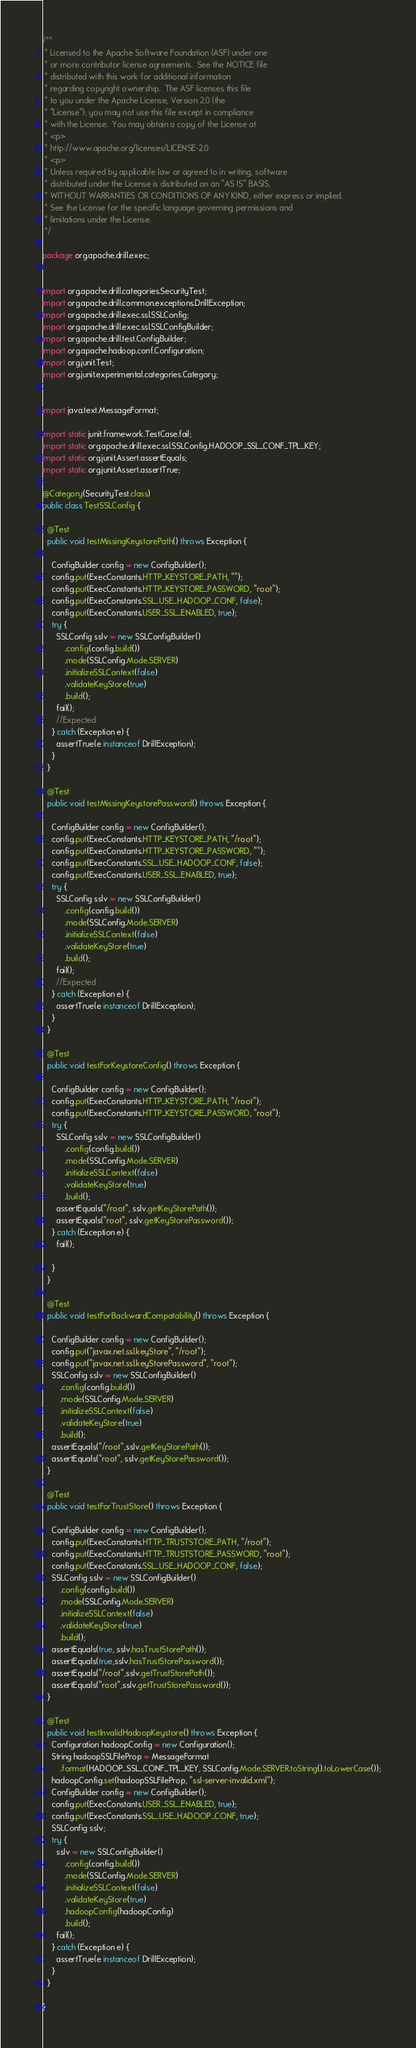Convert code to text. <code><loc_0><loc_0><loc_500><loc_500><_Java_>/**
 * Licensed to the Apache Software Foundation (ASF) under one
 * or more contributor license agreements.  See the NOTICE file
 * distributed with this work for additional information
 * regarding copyright ownership.  The ASF licenses this file
 * to you under the Apache License, Version 2.0 (the
 * "License"); you may not use this file except in compliance
 * with the License.  You may obtain a copy of the License at
 * <p>
 * http://www.apache.org/licenses/LICENSE-2.0
 * <p>
 * Unless required by applicable law or agreed to in writing, software
 * distributed under the License is distributed on an "AS IS" BASIS,
 * WITHOUT WARRANTIES OR CONDITIONS OF ANY KIND, either express or implied.
 * See the License for the specific language governing permissions and
 * limitations under the License.
 */

package org.apache.drill.exec;


import org.apache.drill.categories.SecurityTest;
import org.apache.drill.common.exceptions.DrillException;
import org.apache.drill.exec.ssl.SSLConfig;
import org.apache.drill.exec.ssl.SSLConfigBuilder;
import org.apache.drill.test.ConfigBuilder;
import org.apache.hadoop.conf.Configuration;
import org.junit.Test;
import org.junit.experimental.categories.Category;


import java.text.MessageFormat;

import static junit.framework.TestCase.fail;
import static org.apache.drill.exec.ssl.SSLConfig.HADOOP_SSL_CONF_TPL_KEY;
import static org.junit.Assert.assertEquals;
import static org.junit.Assert.assertTrue;

@Category(SecurityTest.class)
public class TestSSLConfig {

  @Test
  public void testMissingKeystorePath() throws Exception {

    ConfigBuilder config = new ConfigBuilder();
    config.put(ExecConstants.HTTP_KEYSTORE_PATH, "");
    config.put(ExecConstants.HTTP_KEYSTORE_PASSWORD, "root");
    config.put(ExecConstants.SSL_USE_HADOOP_CONF, false);
    config.put(ExecConstants.USER_SSL_ENABLED, true);
    try {
      SSLConfig sslv = new SSLConfigBuilder()
          .config(config.build())
          .mode(SSLConfig.Mode.SERVER)
          .initializeSSLContext(false)
          .validateKeyStore(true)
          .build();
      fail();
      //Expected
    } catch (Exception e) {
      assertTrue(e instanceof DrillException);
    }
  }

  @Test
  public void testMissingKeystorePassword() throws Exception {

    ConfigBuilder config = new ConfigBuilder();
    config.put(ExecConstants.HTTP_KEYSTORE_PATH, "/root");
    config.put(ExecConstants.HTTP_KEYSTORE_PASSWORD, "");
    config.put(ExecConstants.SSL_USE_HADOOP_CONF, false);
    config.put(ExecConstants.USER_SSL_ENABLED, true);
    try {
      SSLConfig sslv = new SSLConfigBuilder()
          .config(config.build())
          .mode(SSLConfig.Mode.SERVER)
          .initializeSSLContext(false)
          .validateKeyStore(true)
          .build();
      fail();
      //Expected
    } catch (Exception e) {
      assertTrue(e instanceof DrillException);
    }
  }

  @Test
  public void testForKeystoreConfig() throws Exception {

    ConfigBuilder config = new ConfigBuilder();
    config.put(ExecConstants.HTTP_KEYSTORE_PATH, "/root");
    config.put(ExecConstants.HTTP_KEYSTORE_PASSWORD, "root");
    try {
      SSLConfig sslv = new SSLConfigBuilder()
          .config(config.build())
          .mode(SSLConfig.Mode.SERVER)
          .initializeSSLContext(false)
          .validateKeyStore(true)
          .build();
      assertEquals("/root", sslv.getKeyStorePath());
      assertEquals("root", sslv.getKeyStorePassword());
    } catch (Exception e) {
      fail();

    }
  }

  @Test
  public void testForBackwardCompatability() throws Exception {

    ConfigBuilder config = new ConfigBuilder();
    config.put("javax.net.ssl.keyStore", "/root");
    config.put("javax.net.ssl.keyStorePassword", "root");
    SSLConfig sslv = new SSLConfigBuilder()
        .config(config.build())
        .mode(SSLConfig.Mode.SERVER)
        .initializeSSLContext(false)
        .validateKeyStore(true)
        .build();
    assertEquals("/root",sslv.getKeyStorePath());
    assertEquals("root", sslv.getKeyStorePassword());
  }

  @Test
  public void testForTrustStore() throws Exception {

    ConfigBuilder config = new ConfigBuilder();
    config.put(ExecConstants.HTTP_TRUSTSTORE_PATH, "/root");
    config.put(ExecConstants.HTTP_TRUSTSTORE_PASSWORD, "root");
    config.put(ExecConstants.SSL_USE_HADOOP_CONF, false);
    SSLConfig sslv = new SSLConfigBuilder()
        .config(config.build())
        .mode(SSLConfig.Mode.SERVER)
        .initializeSSLContext(false)
        .validateKeyStore(true)
        .build();
    assertEquals(true, sslv.hasTrustStorePath());
    assertEquals(true,sslv.hasTrustStorePassword());
    assertEquals("/root",sslv.getTrustStorePath());
    assertEquals("root",sslv.getTrustStorePassword());
  }

  @Test
  public void testInvalidHadoopKeystore() throws Exception {
    Configuration hadoopConfig = new Configuration();
    String hadoopSSLFileProp = MessageFormat
        .format(HADOOP_SSL_CONF_TPL_KEY, SSLConfig.Mode.SERVER.toString().toLowerCase());
    hadoopConfig.set(hadoopSSLFileProp, "ssl-server-invalid.xml");
    ConfigBuilder config = new ConfigBuilder();
    config.put(ExecConstants.USER_SSL_ENABLED, true);
    config.put(ExecConstants.SSL_USE_HADOOP_CONF, true);
    SSLConfig sslv;
    try {
      sslv = new SSLConfigBuilder()
          .config(config.build())
          .mode(SSLConfig.Mode.SERVER)
          .initializeSSLContext(false)
          .validateKeyStore(true)
          .hadoopConfig(hadoopConfig)
          .build();
      fail();
    } catch (Exception e) {
      assertTrue(e instanceof DrillException);
    }
  }

}
</code> 